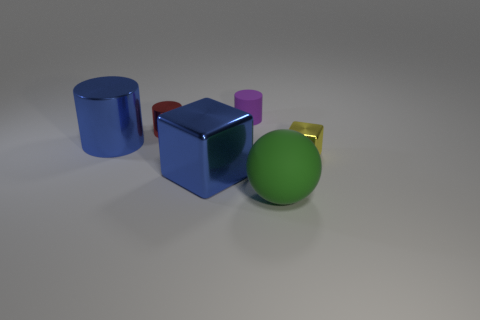What is the material of the large cylinder that is the same color as the big block?
Give a very brief answer. Metal. There is a cylinder in front of the red cylinder; is its size the same as the yellow object?
Offer a terse response. No. There is a block that is on the left side of the yellow object; is its color the same as the large shiny cylinder?
Your answer should be compact. Yes. What number of brown objects are large rubber objects or matte objects?
Make the answer very short. 0. There is a tiny object that is to the right of the tiny red metallic cylinder and left of the tiny yellow block; what is its material?
Offer a very short reply. Rubber. Does the red thing have the same material as the tiny cube?
Offer a terse response. Yes. What number of other metallic cylinders are the same size as the purple cylinder?
Keep it short and to the point. 1. Are there an equal number of yellow cubes left of the large blue metal cylinder and tiny purple rubber spheres?
Your answer should be compact. Yes. How many things are both behind the green thing and to the right of the small matte object?
Your answer should be compact. 1. There is a big blue metal thing that is on the right side of the large blue cylinder; does it have the same shape as the tiny yellow metallic object?
Ensure brevity in your answer.  Yes. 